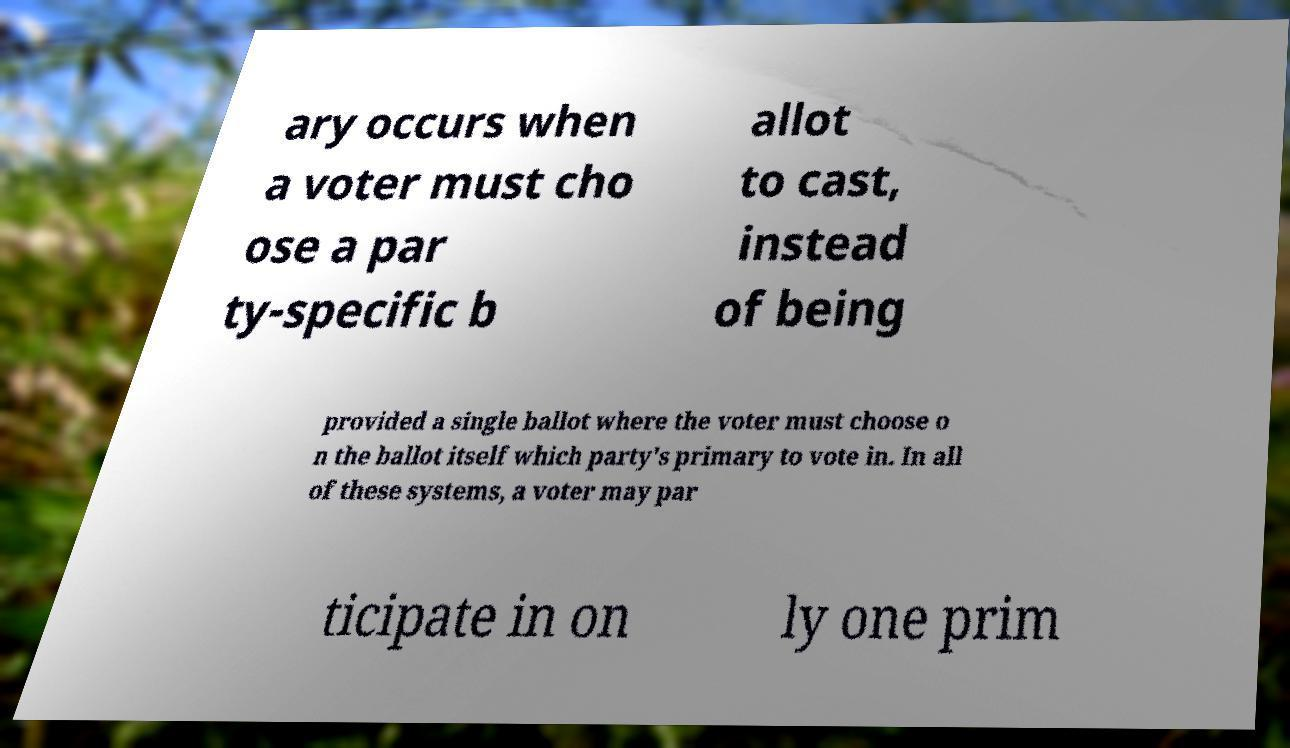What messages or text are displayed in this image? I need them in a readable, typed format. ary occurs when a voter must cho ose a par ty-specific b allot to cast, instead of being provided a single ballot where the voter must choose o n the ballot itself which party's primary to vote in. In all of these systems, a voter may par ticipate in on ly one prim 